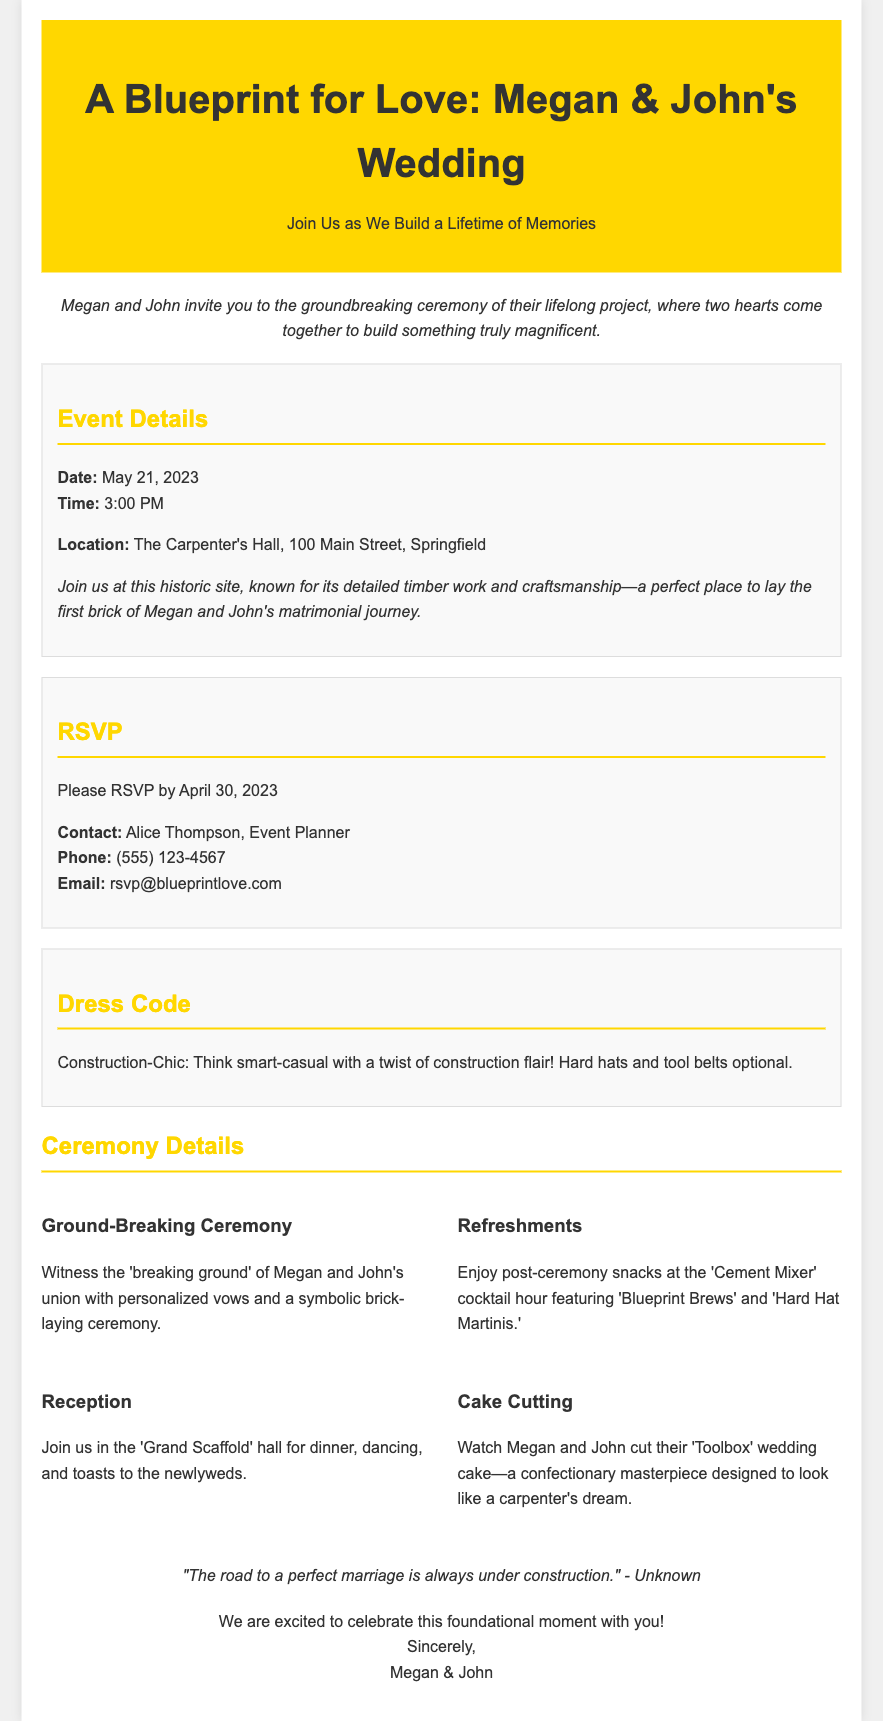What is the date of the wedding? The date of the wedding is mentioned clearly in the document as May 21, 2023.
Answer: May 21, 2023 Who is the event planner? The event planner is specified in the RSVP section of the document as Alice Thompson.
Answer: Alice Thompson What is the location of the ceremony? The venue for the ceremony is provided in the details section as The Carpenter's Hall, 100 Main Street, Springfield.
Answer: The Carpenter's Hall, 100 Main Street, Springfield What is the dress code for the wedding? The dress code is described as Construction-Chic, detailed in the document under Dress Code.
Answer: Construction-Chic What unique feature is included in the ceremony? The ceremony includes a 'breaking ground' moment with personalized vows and a symbolic brick-laying ceremony.
Answer: Symbolic brick-laying ceremony What kind of refreshments will be served? The refreshments offered during the cocktail hour are themed and named, such as 'Blueprint Brews' and 'Hard Hat Martinis.'
Answer: 'Blueprint Brews' and 'Hard Hat Martinis' What will the wedding cake resemble? The wedding cake is designed to look like a carpenter's dream, referred to as the 'Toolbox' wedding cake.
Answer: Toolbox What quote is included in the invitation? A quote from an unknown author about marriage being 'under construction' is included and displayed prominently.
Answer: "The road to a perfect marriage is always under construction." What is the time of the wedding ceremony? The time for the wedding ceremony is given in the details section as 3:00 PM.
Answer: 3:00 PM 